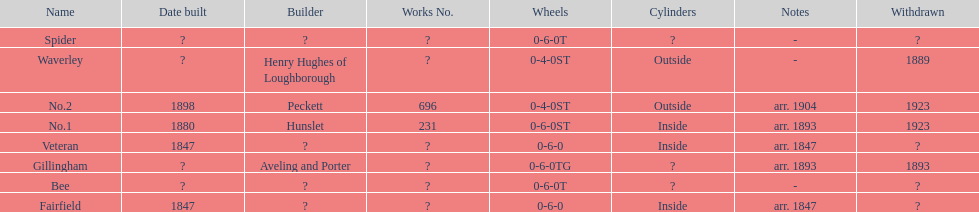What is the total number of names on the chart? 8. 